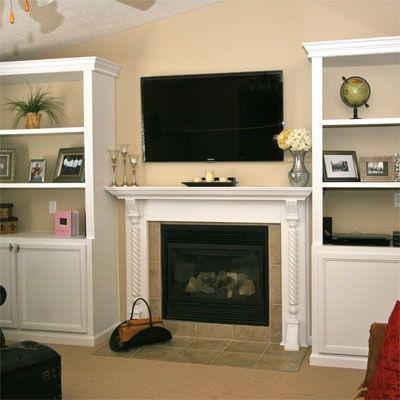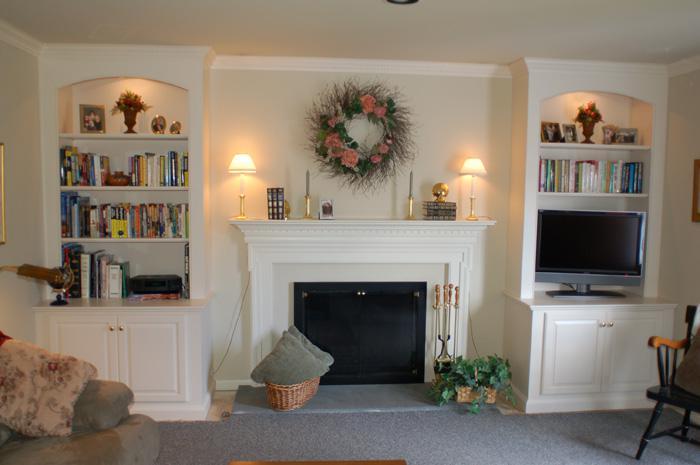The first image is the image on the left, the second image is the image on the right. For the images displayed, is the sentence "There are two chair with cream and blue pillows that match the the line painting on the mantle." factually correct? Answer yes or no. No. The first image is the image on the left, the second image is the image on the right. Assess this claim about the two images: "One image shows white bookcases with arch shapes above the top shelves, flanking a fireplace that does not have a television mounted above it.". Correct or not? Answer yes or no. Yes. 